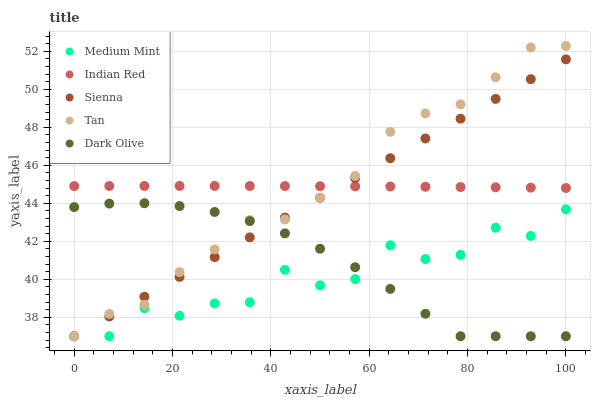Does Medium Mint have the minimum area under the curve?
Answer yes or no. Yes. Does Indian Red have the maximum area under the curve?
Answer yes or no. Yes. Does Sienna have the minimum area under the curve?
Answer yes or no. No. Does Sienna have the maximum area under the curve?
Answer yes or no. No. Is Sienna the smoothest?
Answer yes or no. Yes. Is Medium Mint the roughest?
Answer yes or no. Yes. Is Tan the smoothest?
Answer yes or no. No. Is Tan the roughest?
Answer yes or no. No. Does Medium Mint have the lowest value?
Answer yes or no. Yes. Does Indian Red have the lowest value?
Answer yes or no. No. Does Tan have the highest value?
Answer yes or no. Yes. Does Sienna have the highest value?
Answer yes or no. No. Is Dark Olive less than Indian Red?
Answer yes or no. Yes. Is Indian Red greater than Dark Olive?
Answer yes or no. Yes. Does Tan intersect Dark Olive?
Answer yes or no. Yes. Is Tan less than Dark Olive?
Answer yes or no. No. Is Tan greater than Dark Olive?
Answer yes or no. No. Does Dark Olive intersect Indian Red?
Answer yes or no. No. 